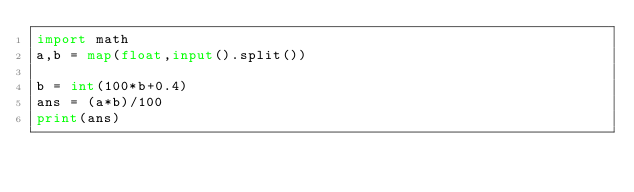Convert code to text. <code><loc_0><loc_0><loc_500><loc_500><_Python_>import math
a,b = map(float,input().split())

b = int(100*b+0.4)
ans = (a*b)/100
print(ans)</code> 